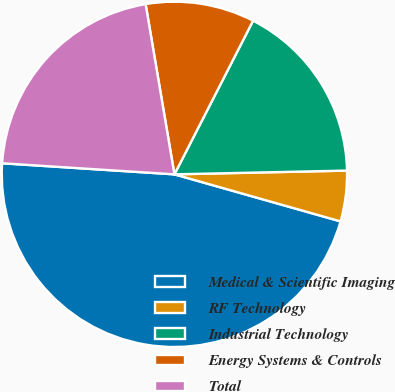Convert chart. <chart><loc_0><loc_0><loc_500><loc_500><pie_chart><fcel>Medical & Scientific Imaging<fcel>RF Technology<fcel>Industrial Technology<fcel>Energy Systems & Controls<fcel>Total<nl><fcel>46.63%<fcel>4.74%<fcel>17.12%<fcel>10.2%<fcel>21.31%<nl></chart> 